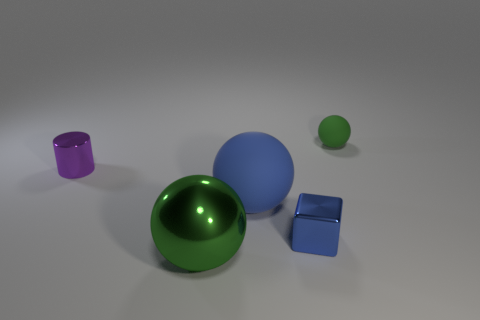Is there anything else that has the same shape as the small blue thing?
Provide a short and direct response. No. The small matte sphere is what color?
Ensure brevity in your answer.  Green. There is a green thing behind the shiny sphere; how many objects are in front of it?
Your response must be concise. 4. Does the blue matte thing have the same size as the shiny object right of the green shiny sphere?
Make the answer very short. No. Does the green metallic thing have the same size as the green matte thing?
Keep it short and to the point. No. Is there a blue shiny thing that has the same size as the purple shiny thing?
Your response must be concise. Yes. There is a green ball that is in front of the small shiny cylinder; what material is it?
Offer a very short reply. Metal. What is the color of the tiny block that is made of the same material as the tiny cylinder?
Provide a succinct answer. Blue. What number of metallic things are either yellow objects or blocks?
Offer a terse response. 1. What is the shape of the metal object that is the same size as the blue shiny cube?
Make the answer very short. Cylinder. 